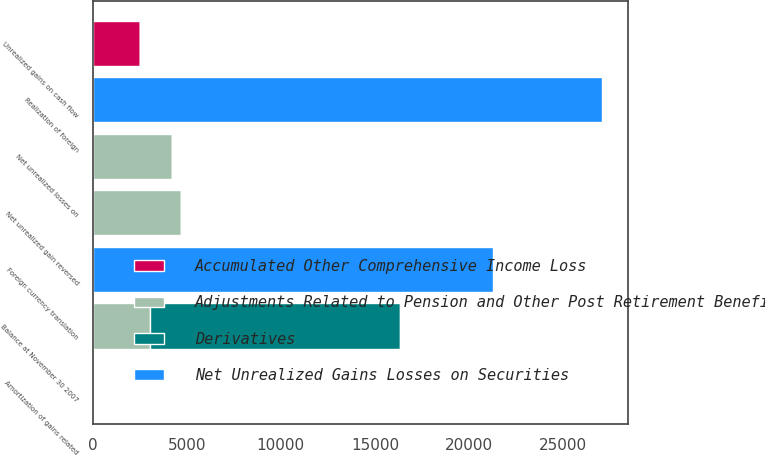Convert chart to OTSL. <chart><loc_0><loc_0><loc_500><loc_500><stacked_bar_chart><ecel><fcel>Balance at November 30 2007<fcel>Net unrealized losses on<fcel>Foreign currency translation<fcel>Realization of foreign<fcel>Net unrealized gain reversed<fcel>Amortization of gains related<fcel>Unrealized gains on cash flow<nl><fcel>Adjustments Related to Pension and Other Post Retirement Benefits<fcel>3061<fcel>4213<fcel>0<fcel>0<fcel>4681<fcel>0<fcel>0<nl><fcel>Net Unrealized Gains Losses on Securities<fcel>0<fcel>0<fcel>21282<fcel>27076<fcel>0<fcel>0<fcel>0<nl><fcel>Derivatives<fcel>13265<fcel>0<fcel>0<fcel>0<fcel>0<fcel>78<fcel>0<nl><fcel>Accumulated Other Comprehensive Income Loss<fcel>0<fcel>0<fcel>0<fcel>0<fcel>0<fcel>0<fcel>2525<nl></chart> 